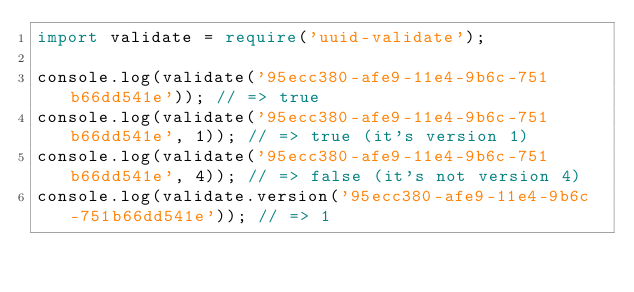Convert code to text. <code><loc_0><loc_0><loc_500><loc_500><_TypeScript_>import validate = require('uuid-validate');

console.log(validate('95ecc380-afe9-11e4-9b6c-751b66dd541e')); // => true
console.log(validate('95ecc380-afe9-11e4-9b6c-751b66dd541e', 1)); // => true (it's version 1)
console.log(validate('95ecc380-afe9-11e4-9b6c-751b66dd541e', 4)); // => false (it's not version 4)
console.log(validate.version('95ecc380-afe9-11e4-9b6c-751b66dd541e')); // => 1
</code> 